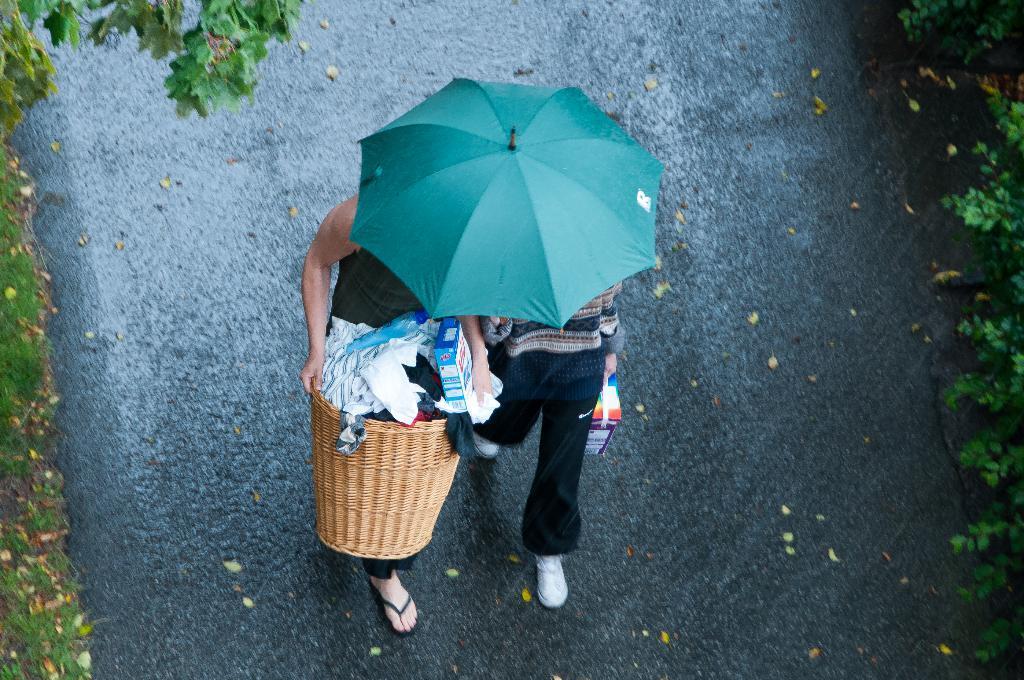Describe this image in one or two sentences. Here we can see two people. This person is holding a basket with clothes and box. This is a green umbrella. Left side of the image and right side of the image we can see green leaves.  